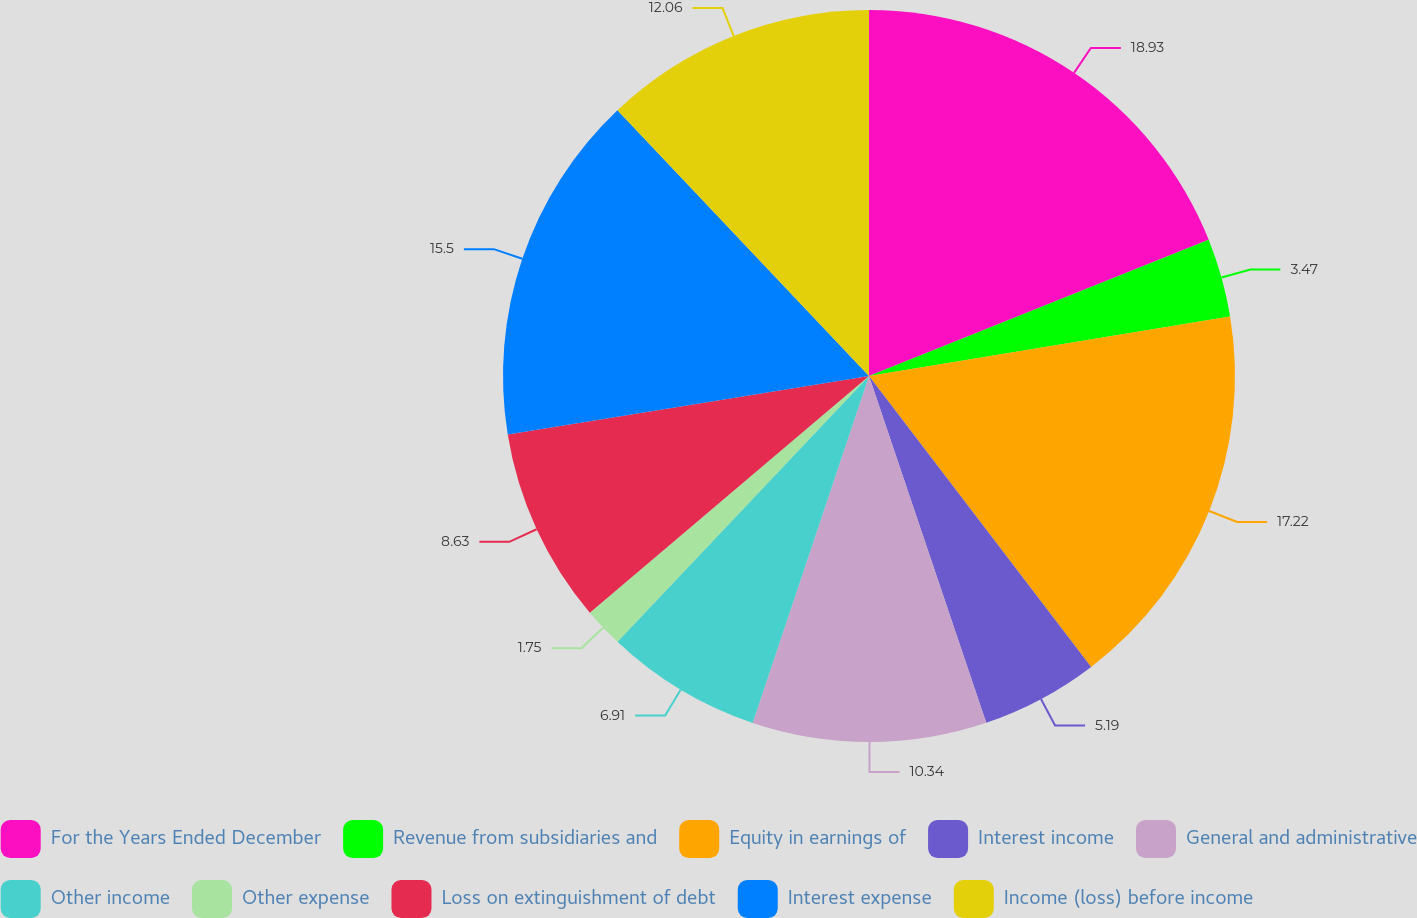<chart> <loc_0><loc_0><loc_500><loc_500><pie_chart><fcel>For the Years Ended December<fcel>Revenue from subsidiaries and<fcel>Equity in earnings of<fcel>Interest income<fcel>General and administrative<fcel>Other income<fcel>Other expense<fcel>Loss on extinguishment of debt<fcel>Interest expense<fcel>Income (loss) before income<nl><fcel>18.93%<fcel>3.47%<fcel>17.22%<fcel>5.19%<fcel>10.34%<fcel>6.91%<fcel>1.75%<fcel>8.63%<fcel>15.5%<fcel>12.06%<nl></chart> 